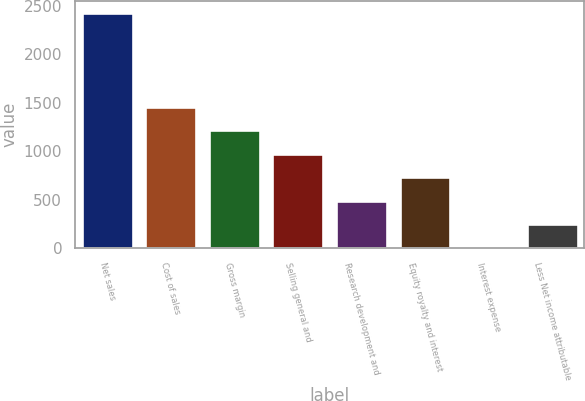<chart> <loc_0><loc_0><loc_500><loc_500><bar_chart><fcel>Net sales<fcel>Cost of sales<fcel>Gross margin<fcel>Selling general and<fcel>Research development and<fcel>Equity royalty and interest<fcel>Interest expense<fcel>Less Net income attributable<nl><fcel>2426<fcel>1457.6<fcel>1215.5<fcel>973.4<fcel>489.2<fcel>731.3<fcel>5<fcel>247.1<nl></chart> 